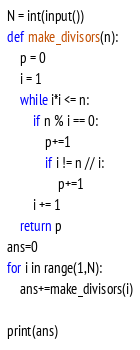<code> <loc_0><loc_0><loc_500><loc_500><_Python_>N = int(input())
def make_divisors(n):
    p = 0
    i = 1
    while i*i <= n:
        if n % i == 0:
            p+=1
            if i != n // i:
                p+=1
        i += 1
    return p
ans=0
for i in range(1,N):
    ans+=make_divisors(i)

print(ans)</code> 